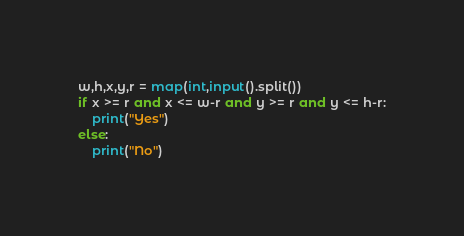<code> <loc_0><loc_0><loc_500><loc_500><_Python_>w,h,x,y,r = map(int,input().split())
if x >= r and x <= w-r and y >= r and y <= h-r:
    print("Yes")
else:
    print("No")


</code> 